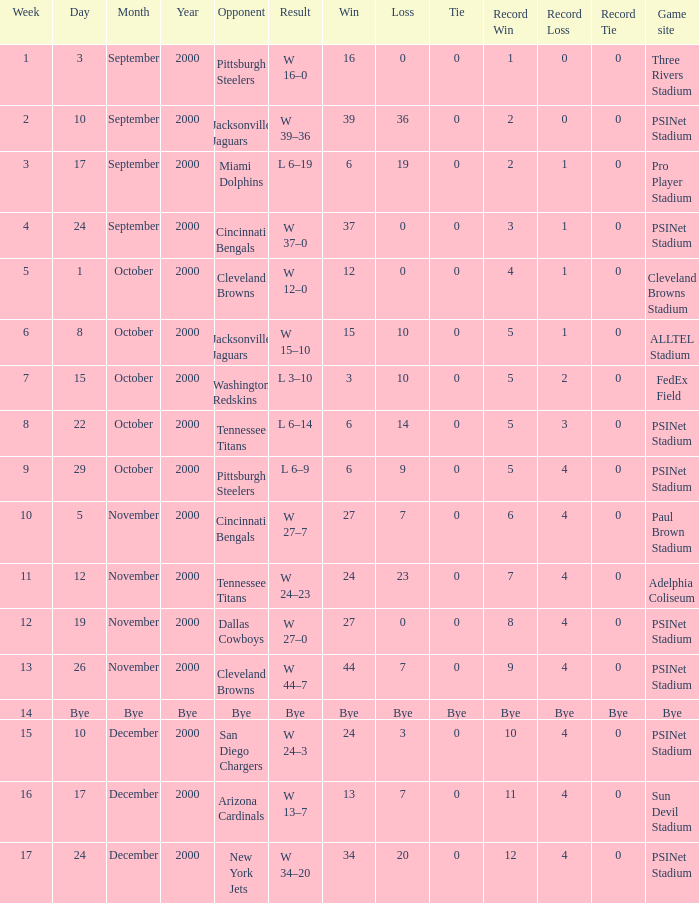What's the record after week 12 with a game site of bye? Bye. 